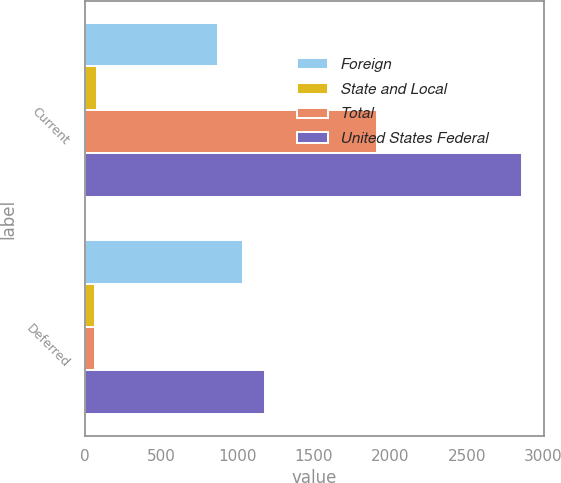Convert chart to OTSL. <chart><loc_0><loc_0><loc_500><loc_500><stacked_bar_chart><ecel><fcel>Current<fcel>Deferred<nl><fcel>Foreign<fcel>870<fcel>1037<nl><fcel>State and Local<fcel>81<fcel>71<nl><fcel>Total<fcel>1912<fcel>70<nl><fcel>United States Federal<fcel>2863<fcel>1178<nl></chart> 